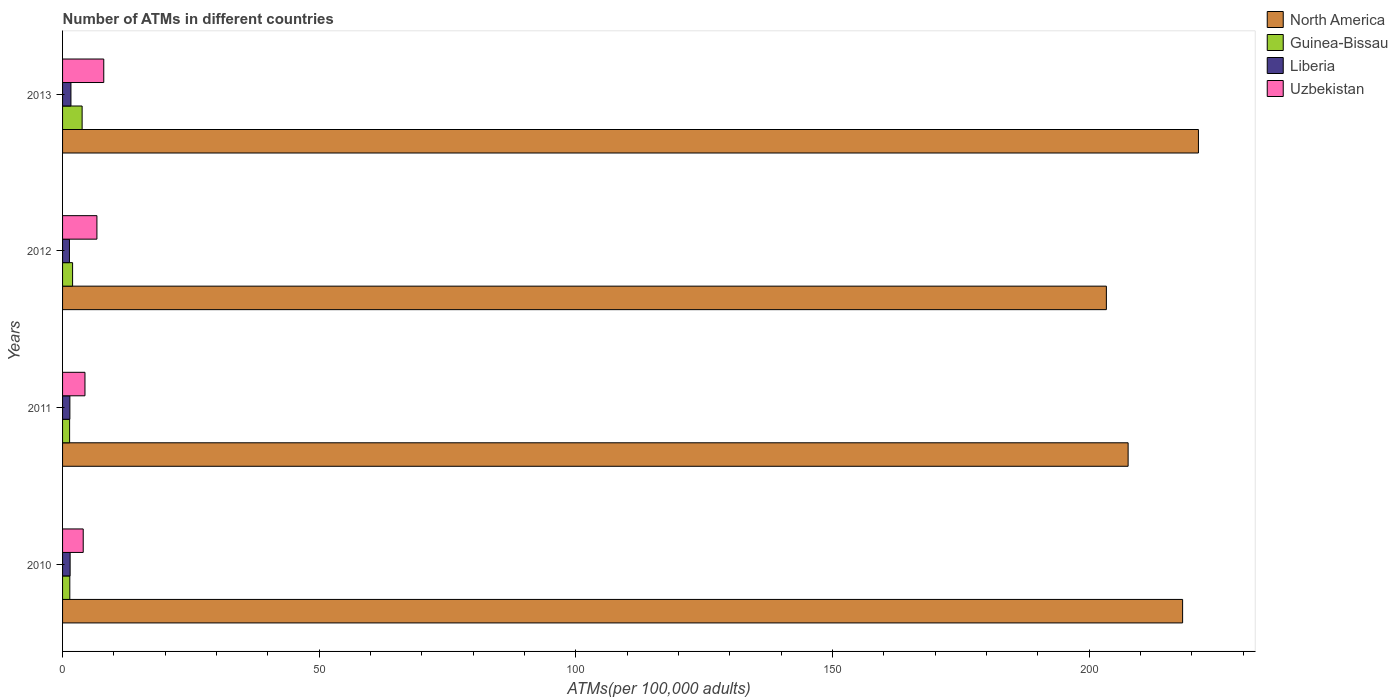How many bars are there on the 4th tick from the top?
Offer a terse response. 4. What is the number of ATMs in Guinea-Bissau in 2013?
Your response must be concise. 3.81. Across all years, what is the maximum number of ATMs in Liberia?
Provide a succinct answer. 1.63. Across all years, what is the minimum number of ATMs in Liberia?
Your answer should be compact. 1.34. In which year was the number of ATMs in North America maximum?
Offer a terse response. 2013. What is the total number of ATMs in Uzbekistan in the graph?
Your answer should be compact. 23.11. What is the difference between the number of ATMs in North America in 2011 and that in 2012?
Your answer should be very brief. 4.24. What is the difference between the number of ATMs in Uzbekistan in 2011 and the number of ATMs in Liberia in 2012?
Make the answer very short. 3.02. What is the average number of ATMs in Uzbekistan per year?
Your response must be concise. 5.78. In the year 2013, what is the difference between the number of ATMs in North America and number of ATMs in Uzbekistan?
Your answer should be very brief. 213.23. What is the ratio of the number of ATMs in Uzbekistan in 2010 to that in 2012?
Your response must be concise. 0.6. Is the difference between the number of ATMs in North America in 2010 and 2012 greater than the difference between the number of ATMs in Uzbekistan in 2010 and 2012?
Your answer should be very brief. Yes. What is the difference between the highest and the second highest number of ATMs in Guinea-Bissau?
Provide a short and direct response. 1.85. What is the difference between the highest and the lowest number of ATMs in Uzbekistan?
Offer a terse response. 4. What does the 3rd bar from the top in 2013 represents?
Provide a short and direct response. Guinea-Bissau. What does the 4th bar from the bottom in 2012 represents?
Offer a very short reply. Uzbekistan. How many bars are there?
Offer a very short reply. 16. How many years are there in the graph?
Make the answer very short. 4. What is the difference between two consecutive major ticks on the X-axis?
Offer a terse response. 50. Where does the legend appear in the graph?
Offer a terse response. Top right. How many legend labels are there?
Keep it short and to the point. 4. How are the legend labels stacked?
Your answer should be compact. Vertical. What is the title of the graph?
Provide a succinct answer. Number of ATMs in different countries. What is the label or title of the X-axis?
Your response must be concise. ATMs(per 100,0 adults). What is the label or title of the Y-axis?
Provide a short and direct response. Years. What is the ATMs(per 100,000 adults) in North America in 2010?
Provide a succinct answer. 218.18. What is the ATMs(per 100,000 adults) of Guinea-Bissau in 2010?
Make the answer very short. 1.41. What is the ATMs(per 100,000 adults) of Liberia in 2010?
Keep it short and to the point. 1.47. What is the ATMs(per 100,000 adults) of Uzbekistan in 2010?
Make the answer very short. 4.02. What is the ATMs(per 100,000 adults) in North America in 2011?
Provide a succinct answer. 207.56. What is the ATMs(per 100,000 adults) in Guinea-Bissau in 2011?
Offer a terse response. 1.37. What is the ATMs(per 100,000 adults) of Liberia in 2011?
Give a very brief answer. 1.42. What is the ATMs(per 100,000 adults) in Uzbekistan in 2011?
Your response must be concise. 4.36. What is the ATMs(per 100,000 adults) of North America in 2012?
Offer a terse response. 203.33. What is the ATMs(per 100,000 adults) of Guinea-Bissau in 2012?
Provide a short and direct response. 1.95. What is the ATMs(per 100,000 adults) in Liberia in 2012?
Provide a succinct answer. 1.34. What is the ATMs(per 100,000 adults) of Uzbekistan in 2012?
Your answer should be compact. 6.69. What is the ATMs(per 100,000 adults) in North America in 2013?
Make the answer very short. 221.26. What is the ATMs(per 100,000 adults) of Guinea-Bissau in 2013?
Make the answer very short. 3.81. What is the ATMs(per 100,000 adults) of Liberia in 2013?
Provide a short and direct response. 1.63. What is the ATMs(per 100,000 adults) in Uzbekistan in 2013?
Ensure brevity in your answer.  8.03. Across all years, what is the maximum ATMs(per 100,000 adults) in North America?
Provide a succinct answer. 221.26. Across all years, what is the maximum ATMs(per 100,000 adults) of Guinea-Bissau?
Your answer should be very brief. 3.81. Across all years, what is the maximum ATMs(per 100,000 adults) of Liberia?
Your answer should be compact. 1.63. Across all years, what is the maximum ATMs(per 100,000 adults) in Uzbekistan?
Ensure brevity in your answer.  8.03. Across all years, what is the minimum ATMs(per 100,000 adults) in North America?
Offer a terse response. 203.33. Across all years, what is the minimum ATMs(per 100,000 adults) in Guinea-Bissau?
Keep it short and to the point. 1.37. Across all years, what is the minimum ATMs(per 100,000 adults) in Liberia?
Offer a terse response. 1.34. Across all years, what is the minimum ATMs(per 100,000 adults) in Uzbekistan?
Your answer should be very brief. 4.02. What is the total ATMs(per 100,000 adults) in North America in the graph?
Your answer should be compact. 850.33. What is the total ATMs(per 100,000 adults) in Guinea-Bissau in the graph?
Your answer should be very brief. 8.55. What is the total ATMs(per 100,000 adults) of Liberia in the graph?
Offer a terse response. 5.87. What is the total ATMs(per 100,000 adults) of Uzbekistan in the graph?
Your answer should be compact. 23.11. What is the difference between the ATMs(per 100,000 adults) in North America in 2010 and that in 2011?
Keep it short and to the point. 10.61. What is the difference between the ATMs(per 100,000 adults) of Guinea-Bissau in 2010 and that in 2011?
Provide a short and direct response. 0.04. What is the difference between the ATMs(per 100,000 adults) of Liberia in 2010 and that in 2011?
Your answer should be compact. 0.05. What is the difference between the ATMs(per 100,000 adults) of Uzbekistan in 2010 and that in 2011?
Keep it short and to the point. -0.34. What is the difference between the ATMs(per 100,000 adults) of North America in 2010 and that in 2012?
Provide a short and direct response. 14.85. What is the difference between the ATMs(per 100,000 adults) in Guinea-Bissau in 2010 and that in 2012?
Offer a very short reply. -0.54. What is the difference between the ATMs(per 100,000 adults) of Liberia in 2010 and that in 2012?
Your response must be concise. 0.13. What is the difference between the ATMs(per 100,000 adults) of Uzbekistan in 2010 and that in 2012?
Offer a very short reply. -2.67. What is the difference between the ATMs(per 100,000 adults) in North America in 2010 and that in 2013?
Offer a very short reply. -3.08. What is the difference between the ATMs(per 100,000 adults) in Guinea-Bissau in 2010 and that in 2013?
Make the answer very short. -2.4. What is the difference between the ATMs(per 100,000 adults) in Liberia in 2010 and that in 2013?
Make the answer very short. -0.16. What is the difference between the ATMs(per 100,000 adults) of Uzbekistan in 2010 and that in 2013?
Offer a terse response. -4. What is the difference between the ATMs(per 100,000 adults) of North America in 2011 and that in 2012?
Offer a terse response. 4.24. What is the difference between the ATMs(per 100,000 adults) in Guinea-Bissau in 2011 and that in 2012?
Make the answer very short. -0.58. What is the difference between the ATMs(per 100,000 adults) in Liberia in 2011 and that in 2012?
Your answer should be compact. 0.08. What is the difference between the ATMs(per 100,000 adults) of Uzbekistan in 2011 and that in 2012?
Make the answer very short. -2.33. What is the difference between the ATMs(per 100,000 adults) of North America in 2011 and that in 2013?
Your response must be concise. -13.7. What is the difference between the ATMs(per 100,000 adults) in Guinea-Bissau in 2011 and that in 2013?
Make the answer very short. -2.44. What is the difference between the ATMs(per 100,000 adults) of Liberia in 2011 and that in 2013?
Your response must be concise. -0.21. What is the difference between the ATMs(per 100,000 adults) of Uzbekistan in 2011 and that in 2013?
Keep it short and to the point. -3.66. What is the difference between the ATMs(per 100,000 adults) in North America in 2012 and that in 2013?
Provide a short and direct response. -17.93. What is the difference between the ATMs(per 100,000 adults) of Guinea-Bissau in 2012 and that in 2013?
Your answer should be compact. -1.85. What is the difference between the ATMs(per 100,000 adults) in Liberia in 2012 and that in 2013?
Your answer should be compact. -0.29. What is the difference between the ATMs(per 100,000 adults) in Uzbekistan in 2012 and that in 2013?
Your response must be concise. -1.33. What is the difference between the ATMs(per 100,000 adults) of North America in 2010 and the ATMs(per 100,000 adults) of Guinea-Bissau in 2011?
Provide a succinct answer. 216.8. What is the difference between the ATMs(per 100,000 adults) in North America in 2010 and the ATMs(per 100,000 adults) in Liberia in 2011?
Provide a short and direct response. 216.75. What is the difference between the ATMs(per 100,000 adults) of North America in 2010 and the ATMs(per 100,000 adults) of Uzbekistan in 2011?
Ensure brevity in your answer.  213.81. What is the difference between the ATMs(per 100,000 adults) of Guinea-Bissau in 2010 and the ATMs(per 100,000 adults) of Liberia in 2011?
Ensure brevity in your answer.  -0.01. What is the difference between the ATMs(per 100,000 adults) of Guinea-Bissau in 2010 and the ATMs(per 100,000 adults) of Uzbekistan in 2011?
Make the answer very short. -2.95. What is the difference between the ATMs(per 100,000 adults) in Liberia in 2010 and the ATMs(per 100,000 adults) in Uzbekistan in 2011?
Ensure brevity in your answer.  -2.89. What is the difference between the ATMs(per 100,000 adults) in North America in 2010 and the ATMs(per 100,000 adults) in Guinea-Bissau in 2012?
Make the answer very short. 216.22. What is the difference between the ATMs(per 100,000 adults) in North America in 2010 and the ATMs(per 100,000 adults) in Liberia in 2012?
Make the answer very short. 216.84. What is the difference between the ATMs(per 100,000 adults) of North America in 2010 and the ATMs(per 100,000 adults) of Uzbekistan in 2012?
Provide a succinct answer. 211.48. What is the difference between the ATMs(per 100,000 adults) of Guinea-Bissau in 2010 and the ATMs(per 100,000 adults) of Liberia in 2012?
Give a very brief answer. 0.07. What is the difference between the ATMs(per 100,000 adults) of Guinea-Bissau in 2010 and the ATMs(per 100,000 adults) of Uzbekistan in 2012?
Keep it short and to the point. -5.28. What is the difference between the ATMs(per 100,000 adults) of Liberia in 2010 and the ATMs(per 100,000 adults) of Uzbekistan in 2012?
Offer a terse response. -5.22. What is the difference between the ATMs(per 100,000 adults) in North America in 2010 and the ATMs(per 100,000 adults) in Guinea-Bissau in 2013?
Offer a terse response. 214.37. What is the difference between the ATMs(per 100,000 adults) in North America in 2010 and the ATMs(per 100,000 adults) in Liberia in 2013?
Offer a very short reply. 216.55. What is the difference between the ATMs(per 100,000 adults) of North America in 2010 and the ATMs(per 100,000 adults) of Uzbekistan in 2013?
Make the answer very short. 210.15. What is the difference between the ATMs(per 100,000 adults) in Guinea-Bissau in 2010 and the ATMs(per 100,000 adults) in Liberia in 2013?
Give a very brief answer. -0.22. What is the difference between the ATMs(per 100,000 adults) in Guinea-Bissau in 2010 and the ATMs(per 100,000 adults) in Uzbekistan in 2013?
Your response must be concise. -6.62. What is the difference between the ATMs(per 100,000 adults) in Liberia in 2010 and the ATMs(per 100,000 adults) in Uzbekistan in 2013?
Keep it short and to the point. -6.55. What is the difference between the ATMs(per 100,000 adults) in North America in 2011 and the ATMs(per 100,000 adults) in Guinea-Bissau in 2012?
Your response must be concise. 205.61. What is the difference between the ATMs(per 100,000 adults) in North America in 2011 and the ATMs(per 100,000 adults) in Liberia in 2012?
Provide a succinct answer. 206.22. What is the difference between the ATMs(per 100,000 adults) in North America in 2011 and the ATMs(per 100,000 adults) in Uzbekistan in 2012?
Your answer should be compact. 200.87. What is the difference between the ATMs(per 100,000 adults) in Guinea-Bissau in 2011 and the ATMs(per 100,000 adults) in Liberia in 2012?
Offer a terse response. 0.03. What is the difference between the ATMs(per 100,000 adults) in Guinea-Bissau in 2011 and the ATMs(per 100,000 adults) in Uzbekistan in 2012?
Provide a short and direct response. -5.32. What is the difference between the ATMs(per 100,000 adults) in Liberia in 2011 and the ATMs(per 100,000 adults) in Uzbekistan in 2012?
Make the answer very short. -5.27. What is the difference between the ATMs(per 100,000 adults) in North America in 2011 and the ATMs(per 100,000 adults) in Guinea-Bissau in 2013?
Provide a succinct answer. 203.75. What is the difference between the ATMs(per 100,000 adults) in North America in 2011 and the ATMs(per 100,000 adults) in Liberia in 2013?
Your answer should be compact. 205.93. What is the difference between the ATMs(per 100,000 adults) of North America in 2011 and the ATMs(per 100,000 adults) of Uzbekistan in 2013?
Provide a short and direct response. 199.54. What is the difference between the ATMs(per 100,000 adults) in Guinea-Bissau in 2011 and the ATMs(per 100,000 adults) in Liberia in 2013?
Provide a short and direct response. -0.26. What is the difference between the ATMs(per 100,000 adults) in Guinea-Bissau in 2011 and the ATMs(per 100,000 adults) in Uzbekistan in 2013?
Your response must be concise. -6.65. What is the difference between the ATMs(per 100,000 adults) of Liberia in 2011 and the ATMs(per 100,000 adults) of Uzbekistan in 2013?
Your answer should be very brief. -6.6. What is the difference between the ATMs(per 100,000 adults) in North America in 2012 and the ATMs(per 100,000 adults) in Guinea-Bissau in 2013?
Your answer should be compact. 199.52. What is the difference between the ATMs(per 100,000 adults) in North America in 2012 and the ATMs(per 100,000 adults) in Liberia in 2013?
Provide a succinct answer. 201.7. What is the difference between the ATMs(per 100,000 adults) of North America in 2012 and the ATMs(per 100,000 adults) of Uzbekistan in 2013?
Offer a very short reply. 195.3. What is the difference between the ATMs(per 100,000 adults) in Guinea-Bissau in 2012 and the ATMs(per 100,000 adults) in Liberia in 2013?
Offer a very short reply. 0.32. What is the difference between the ATMs(per 100,000 adults) in Guinea-Bissau in 2012 and the ATMs(per 100,000 adults) in Uzbekistan in 2013?
Your answer should be very brief. -6.07. What is the difference between the ATMs(per 100,000 adults) of Liberia in 2012 and the ATMs(per 100,000 adults) of Uzbekistan in 2013?
Give a very brief answer. -6.69. What is the average ATMs(per 100,000 adults) of North America per year?
Ensure brevity in your answer.  212.58. What is the average ATMs(per 100,000 adults) of Guinea-Bissau per year?
Keep it short and to the point. 2.14. What is the average ATMs(per 100,000 adults) in Liberia per year?
Your answer should be compact. 1.47. What is the average ATMs(per 100,000 adults) of Uzbekistan per year?
Make the answer very short. 5.78. In the year 2010, what is the difference between the ATMs(per 100,000 adults) of North America and ATMs(per 100,000 adults) of Guinea-Bissau?
Provide a succinct answer. 216.77. In the year 2010, what is the difference between the ATMs(per 100,000 adults) in North America and ATMs(per 100,000 adults) in Liberia?
Give a very brief answer. 216.71. In the year 2010, what is the difference between the ATMs(per 100,000 adults) in North America and ATMs(per 100,000 adults) in Uzbekistan?
Ensure brevity in your answer.  214.15. In the year 2010, what is the difference between the ATMs(per 100,000 adults) of Guinea-Bissau and ATMs(per 100,000 adults) of Liberia?
Offer a terse response. -0.06. In the year 2010, what is the difference between the ATMs(per 100,000 adults) in Guinea-Bissau and ATMs(per 100,000 adults) in Uzbekistan?
Ensure brevity in your answer.  -2.61. In the year 2010, what is the difference between the ATMs(per 100,000 adults) in Liberia and ATMs(per 100,000 adults) in Uzbekistan?
Make the answer very short. -2.55. In the year 2011, what is the difference between the ATMs(per 100,000 adults) in North America and ATMs(per 100,000 adults) in Guinea-Bissau?
Provide a succinct answer. 206.19. In the year 2011, what is the difference between the ATMs(per 100,000 adults) in North America and ATMs(per 100,000 adults) in Liberia?
Offer a terse response. 206.14. In the year 2011, what is the difference between the ATMs(per 100,000 adults) in North America and ATMs(per 100,000 adults) in Uzbekistan?
Offer a terse response. 203.2. In the year 2011, what is the difference between the ATMs(per 100,000 adults) in Guinea-Bissau and ATMs(per 100,000 adults) in Liberia?
Provide a succinct answer. -0.05. In the year 2011, what is the difference between the ATMs(per 100,000 adults) in Guinea-Bissau and ATMs(per 100,000 adults) in Uzbekistan?
Offer a very short reply. -2.99. In the year 2011, what is the difference between the ATMs(per 100,000 adults) of Liberia and ATMs(per 100,000 adults) of Uzbekistan?
Offer a very short reply. -2.94. In the year 2012, what is the difference between the ATMs(per 100,000 adults) in North America and ATMs(per 100,000 adults) in Guinea-Bissau?
Give a very brief answer. 201.37. In the year 2012, what is the difference between the ATMs(per 100,000 adults) of North America and ATMs(per 100,000 adults) of Liberia?
Offer a very short reply. 201.99. In the year 2012, what is the difference between the ATMs(per 100,000 adults) of North America and ATMs(per 100,000 adults) of Uzbekistan?
Give a very brief answer. 196.63. In the year 2012, what is the difference between the ATMs(per 100,000 adults) of Guinea-Bissau and ATMs(per 100,000 adults) of Liberia?
Make the answer very short. 0.61. In the year 2012, what is the difference between the ATMs(per 100,000 adults) of Guinea-Bissau and ATMs(per 100,000 adults) of Uzbekistan?
Keep it short and to the point. -4.74. In the year 2012, what is the difference between the ATMs(per 100,000 adults) of Liberia and ATMs(per 100,000 adults) of Uzbekistan?
Provide a short and direct response. -5.35. In the year 2013, what is the difference between the ATMs(per 100,000 adults) of North America and ATMs(per 100,000 adults) of Guinea-Bissau?
Your answer should be compact. 217.45. In the year 2013, what is the difference between the ATMs(per 100,000 adults) of North America and ATMs(per 100,000 adults) of Liberia?
Offer a terse response. 219.63. In the year 2013, what is the difference between the ATMs(per 100,000 adults) in North America and ATMs(per 100,000 adults) in Uzbekistan?
Offer a terse response. 213.23. In the year 2013, what is the difference between the ATMs(per 100,000 adults) in Guinea-Bissau and ATMs(per 100,000 adults) in Liberia?
Provide a succinct answer. 2.18. In the year 2013, what is the difference between the ATMs(per 100,000 adults) of Guinea-Bissau and ATMs(per 100,000 adults) of Uzbekistan?
Your response must be concise. -4.22. In the year 2013, what is the difference between the ATMs(per 100,000 adults) of Liberia and ATMs(per 100,000 adults) of Uzbekistan?
Offer a terse response. -6.4. What is the ratio of the ATMs(per 100,000 adults) of North America in 2010 to that in 2011?
Offer a very short reply. 1.05. What is the ratio of the ATMs(per 100,000 adults) of Guinea-Bissau in 2010 to that in 2011?
Provide a short and direct response. 1.03. What is the ratio of the ATMs(per 100,000 adults) of Liberia in 2010 to that in 2011?
Offer a very short reply. 1.03. What is the ratio of the ATMs(per 100,000 adults) of Uzbekistan in 2010 to that in 2011?
Keep it short and to the point. 0.92. What is the ratio of the ATMs(per 100,000 adults) in North America in 2010 to that in 2012?
Provide a short and direct response. 1.07. What is the ratio of the ATMs(per 100,000 adults) of Guinea-Bissau in 2010 to that in 2012?
Offer a terse response. 0.72. What is the ratio of the ATMs(per 100,000 adults) of Liberia in 2010 to that in 2012?
Your answer should be compact. 1.1. What is the ratio of the ATMs(per 100,000 adults) in Uzbekistan in 2010 to that in 2012?
Your answer should be very brief. 0.6. What is the ratio of the ATMs(per 100,000 adults) in North America in 2010 to that in 2013?
Your response must be concise. 0.99. What is the ratio of the ATMs(per 100,000 adults) in Guinea-Bissau in 2010 to that in 2013?
Provide a succinct answer. 0.37. What is the ratio of the ATMs(per 100,000 adults) in Liberia in 2010 to that in 2013?
Make the answer very short. 0.9. What is the ratio of the ATMs(per 100,000 adults) in Uzbekistan in 2010 to that in 2013?
Offer a very short reply. 0.5. What is the ratio of the ATMs(per 100,000 adults) in North America in 2011 to that in 2012?
Offer a terse response. 1.02. What is the ratio of the ATMs(per 100,000 adults) of Guinea-Bissau in 2011 to that in 2012?
Provide a short and direct response. 0.7. What is the ratio of the ATMs(per 100,000 adults) of Liberia in 2011 to that in 2012?
Offer a terse response. 1.06. What is the ratio of the ATMs(per 100,000 adults) in Uzbekistan in 2011 to that in 2012?
Make the answer very short. 0.65. What is the ratio of the ATMs(per 100,000 adults) of North America in 2011 to that in 2013?
Provide a succinct answer. 0.94. What is the ratio of the ATMs(per 100,000 adults) in Guinea-Bissau in 2011 to that in 2013?
Give a very brief answer. 0.36. What is the ratio of the ATMs(per 100,000 adults) of Liberia in 2011 to that in 2013?
Provide a succinct answer. 0.87. What is the ratio of the ATMs(per 100,000 adults) in Uzbekistan in 2011 to that in 2013?
Keep it short and to the point. 0.54. What is the ratio of the ATMs(per 100,000 adults) of North America in 2012 to that in 2013?
Provide a short and direct response. 0.92. What is the ratio of the ATMs(per 100,000 adults) of Guinea-Bissau in 2012 to that in 2013?
Keep it short and to the point. 0.51. What is the ratio of the ATMs(per 100,000 adults) in Liberia in 2012 to that in 2013?
Your answer should be very brief. 0.82. What is the ratio of the ATMs(per 100,000 adults) in Uzbekistan in 2012 to that in 2013?
Offer a terse response. 0.83. What is the difference between the highest and the second highest ATMs(per 100,000 adults) of North America?
Provide a succinct answer. 3.08. What is the difference between the highest and the second highest ATMs(per 100,000 adults) of Guinea-Bissau?
Offer a very short reply. 1.85. What is the difference between the highest and the second highest ATMs(per 100,000 adults) of Liberia?
Offer a very short reply. 0.16. What is the difference between the highest and the second highest ATMs(per 100,000 adults) of Uzbekistan?
Your answer should be compact. 1.33. What is the difference between the highest and the lowest ATMs(per 100,000 adults) of North America?
Offer a terse response. 17.93. What is the difference between the highest and the lowest ATMs(per 100,000 adults) in Guinea-Bissau?
Offer a very short reply. 2.44. What is the difference between the highest and the lowest ATMs(per 100,000 adults) of Liberia?
Offer a very short reply. 0.29. What is the difference between the highest and the lowest ATMs(per 100,000 adults) in Uzbekistan?
Ensure brevity in your answer.  4. 